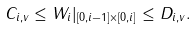<formula> <loc_0><loc_0><loc_500><loc_500>C _ { i , v } \leq W _ { i } | _ { [ 0 , i - 1 ] \times [ 0 , i ] } \leq D _ { i , v } .</formula> 